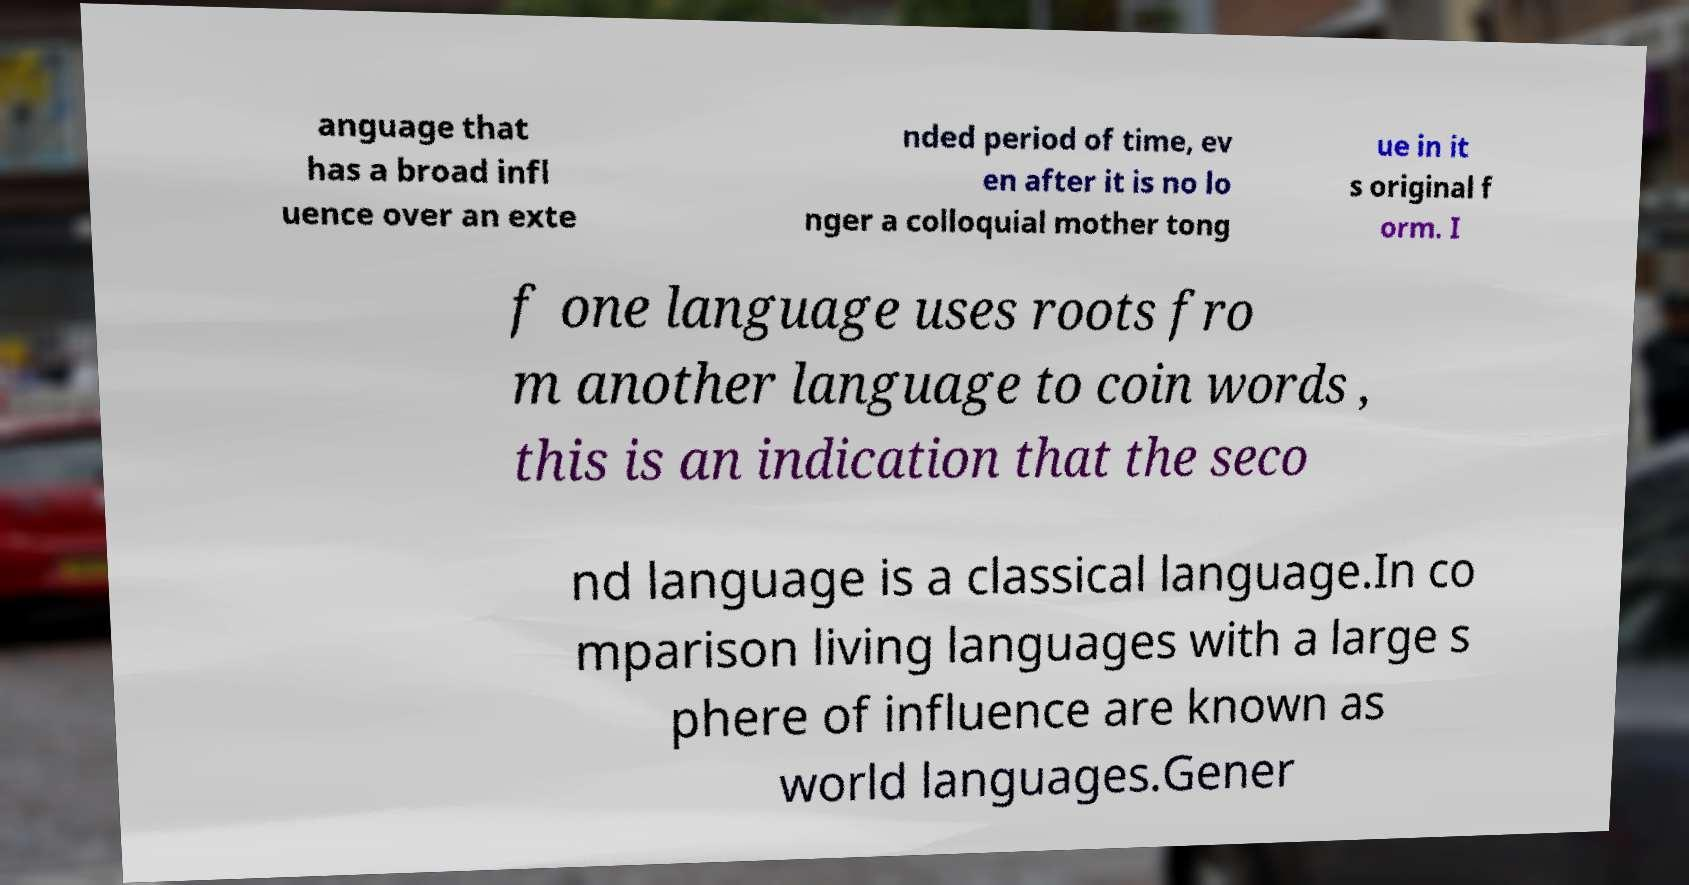Can you accurately transcribe the text from the provided image for me? anguage that has a broad infl uence over an exte nded period of time, ev en after it is no lo nger a colloquial mother tong ue in it s original f orm. I f one language uses roots fro m another language to coin words , this is an indication that the seco nd language is a classical language.In co mparison living languages with a large s phere of influence are known as world languages.Gener 